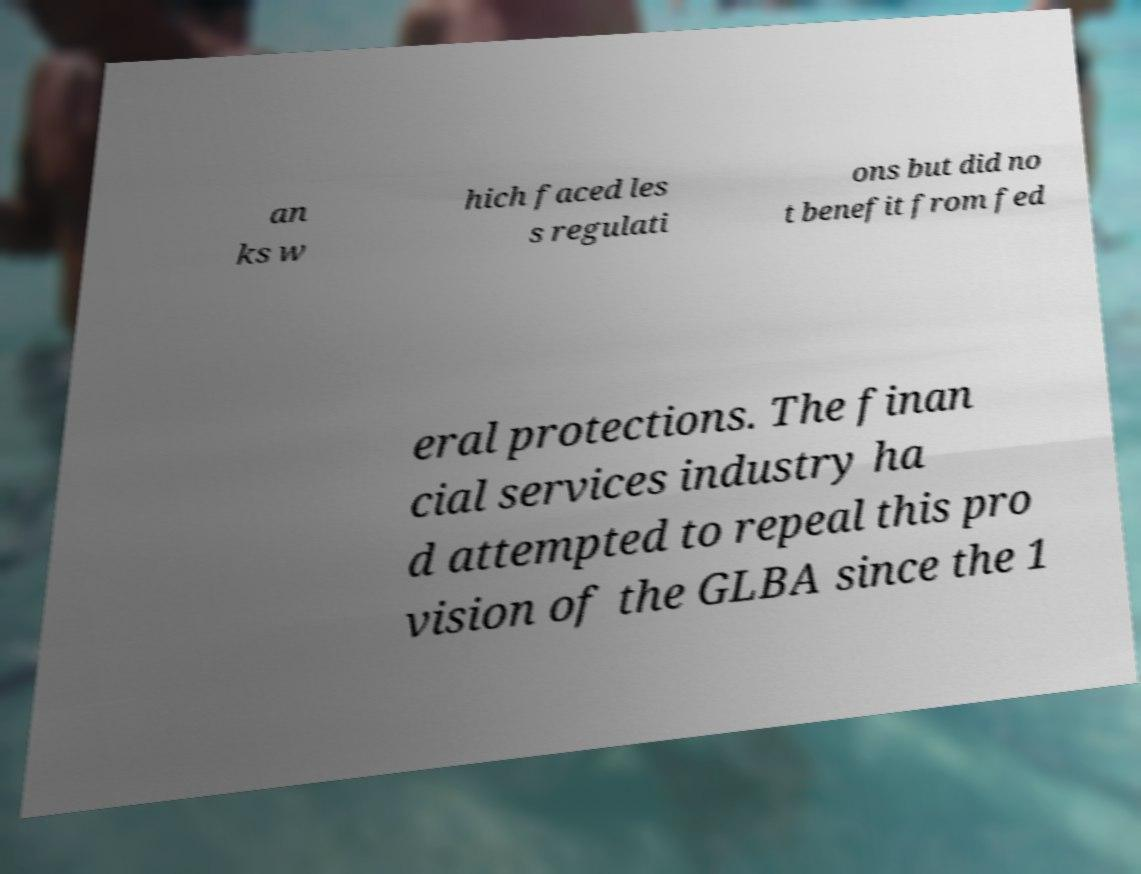There's text embedded in this image that I need extracted. Can you transcribe it verbatim? an ks w hich faced les s regulati ons but did no t benefit from fed eral protections. The finan cial services industry ha d attempted to repeal this pro vision of the GLBA since the 1 